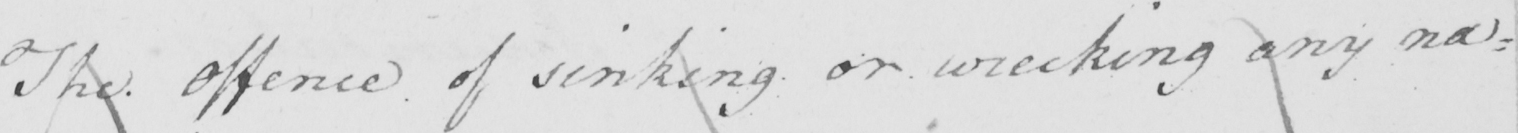Please transcribe the handwritten text in this image. The offence of sinking or wrecking any nav= 